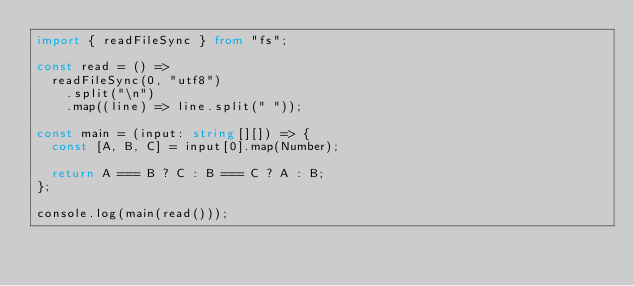<code> <loc_0><loc_0><loc_500><loc_500><_TypeScript_>import { readFileSync } from "fs";

const read = () =>
  readFileSync(0, "utf8")
    .split("\n")
    .map((line) => line.split(" "));

const main = (input: string[][]) => {
  const [A, B, C] = input[0].map(Number);

  return A === B ? C : B === C ? A : B;
};

console.log(main(read()));
</code> 